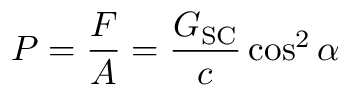<formula> <loc_0><loc_0><loc_500><loc_500>P = { \frac { F } { A } } = { \frac { G _ { S C } } { c } } \cos ^ { 2 } \alpha</formula> 